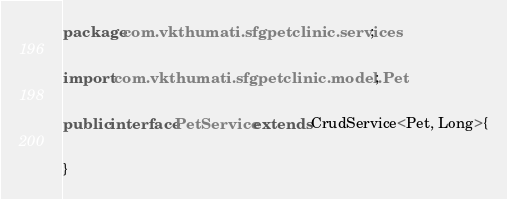Convert code to text. <code><loc_0><loc_0><loc_500><loc_500><_Java_>package com.vkthumati.sfgpetclinic.services;

import com.vkthumati.sfgpetclinic.model.Pet;

public interface PetService extends CrudService<Pet, Long>{

}
</code> 